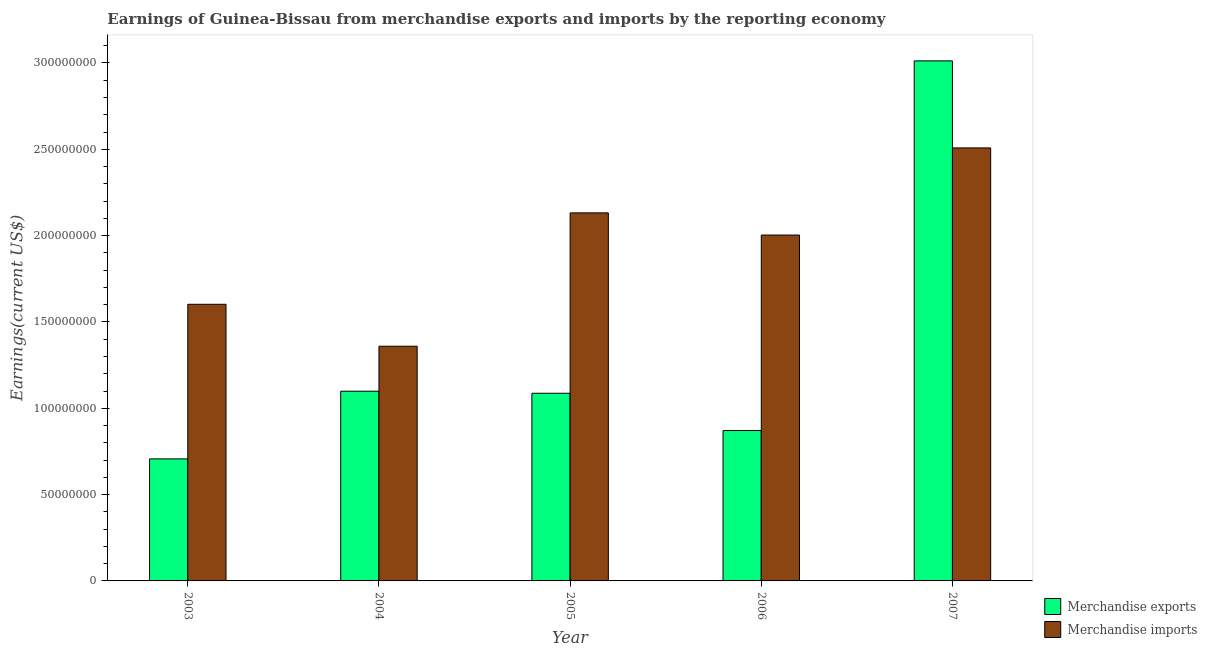Are the number of bars on each tick of the X-axis equal?
Make the answer very short. Yes. How many bars are there on the 1st tick from the right?
Ensure brevity in your answer.  2. What is the label of the 3rd group of bars from the left?
Keep it short and to the point. 2005. What is the earnings from merchandise exports in 2003?
Provide a short and direct response. 7.07e+07. Across all years, what is the maximum earnings from merchandise imports?
Offer a very short reply. 2.51e+08. Across all years, what is the minimum earnings from merchandise exports?
Offer a terse response. 7.07e+07. In which year was the earnings from merchandise exports maximum?
Give a very brief answer. 2007. What is the total earnings from merchandise imports in the graph?
Offer a terse response. 9.61e+08. What is the difference between the earnings from merchandise imports in 2003 and that in 2005?
Offer a terse response. -5.30e+07. What is the difference between the earnings from merchandise imports in 2003 and the earnings from merchandise exports in 2006?
Give a very brief answer. -4.01e+07. What is the average earnings from merchandise imports per year?
Provide a short and direct response. 1.92e+08. In the year 2007, what is the difference between the earnings from merchandise imports and earnings from merchandise exports?
Your response must be concise. 0. In how many years, is the earnings from merchandise imports greater than 40000000 US$?
Give a very brief answer. 5. What is the ratio of the earnings from merchandise imports in 2003 to that in 2007?
Your response must be concise. 0.64. Is the earnings from merchandise imports in 2003 less than that in 2005?
Provide a short and direct response. Yes. Is the difference between the earnings from merchandise exports in 2004 and 2006 greater than the difference between the earnings from merchandise imports in 2004 and 2006?
Your response must be concise. No. What is the difference between the highest and the second highest earnings from merchandise imports?
Provide a succinct answer. 3.76e+07. What is the difference between the highest and the lowest earnings from merchandise imports?
Ensure brevity in your answer.  1.15e+08. How many bars are there?
Give a very brief answer. 10. Are all the bars in the graph horizontal?
Keep it short and to the point. No. How many years are there in the graph?
Give a very brief answer. 5. How are the legend labels stacked?
Ensure brevity in your answer.  Vertical. What is the title of the graph?
Make the answer very short. Earnings of Guinea-Bissau from merchandise exports and imports by the reporting economy. Does "Number of departures" appear as one of the legend labels in the graph?
Provide a short and direct response. No. What is the label or title of the Y-axis?
Provide a short and direct response. Earnings(current US$). What is the Earnings(current US$) in Merchandise exports in 2003?
Give a very brief answer. 7.07e+07. What is the Earnings(current US$) of Merchandise imports in 2003?
Your answer should be compact. 1.60e+08. What is the Earnings(current US$) in Merchandise exports in 2004?
Ensure brevity in your answer.  1.10e+08. What is the Earnings(current US$) of Merchandise imports in 2004?
Keep it short and to the point. 1.36e+08. What is the Earnings(current US$) of Merchandise exports in 2005?
Your response must be concise. 1.09e+08. What is the Earnings(current US$) in Merchandise imports in 2005?
Keep it short and to the point. 2.13e+08. What is the Earnings(current US$) of Merchandise exports in 2006?
Your answer should be compact. 8.71e+07. What is the Earnings(current US$) in Merchandise imports in 2006?
Make the answer very short. 2.00e+08. What is the Earnings(current US$) of Merchandise exports in 2007?
Ensure brevity in your answer.  3.01e+08. What is the Earnings(current US$) of Merchandise imports in 2007?
Make the answer very short. 2.51e+08. Across all years, what is the maximum Earnings(current US$) of Merchandise exports?
Your answer should be very brief. 3.01e+08. Across all years, what is the maximum Earnings(current US$) in Merchandise imports?
Your response must be concise. 2.51e+08. Across all years, what is the minimum Earnings(current US$) of Merchandise exports?
Offer a terse response. 7.07e+07. Across all years, what is the minimum Earnings(current US$) of Merchandise imports?
Your answer should be compact. 1.36e+08. What is the total Earnings(current US$) in Merchandise exports in the graph?
Ensure brevity in your answer.  6.78e+08. What is the total Earnings(current US$) of Merchandise imports in the graph?
Your answer should be very brief. 9.61e+08. What is the difference between the Earnings(current US$) of Merchandise exports in 2003 and that in 2004?
Offer a very short reply. -3.92e+07. What is the difference between the Earnings(current US$) in Merchandise imports in 2003 and that in 2004?
Ensure brevity in your answer.  2.43e+07. What is the difference between the Earnings(current US$) in Merchandise exports in 2003 and that in 2005?
Make the answer very short. -3.80e+07. What is the difference between the Earnings(current US$) of Merchandise imports in 2003 and that in 2005?
Your answer should be very brief. -5.30e+07. What is the difference between the Earnings(current US$) of Merchandise exports in 2003 and that in 2006?
Ensure brevity in your answer.  -1.64e+07. What is the difference between the Earnings(current US$) in Merchandise imports in 2003 and that in 2006?
Give a very brief answer. -4.01e+07. What is the difference between the Earnings(current US$) of Merchandise exports in 2003 and that in 2007?
Make the answer very short. -2.31e+08. What is the difference between the Earnings(current US$) in Merchandise imports in 2003 and that in 2007?
Make the answer very short. -9.06e+07. What is the difference between the Earnings(current US$) in Merchandise exports in 2004 and that in 2005?
Offer a very short reply. 1.20e+06. What is the difference between the Earnings(current US$) in Merchandise imports in 2004 and that in 2005?
Keep it short and to the point. -7.72e+07. What is the difference between the Earnings(current US$) in Merchandise exports in 2004 and that in 2006?
Give a very brief answer. 2.28e+07. What is the difference between the Earnings(current US$) of Merchandise imports in 2004 and that in 2006?
Provide a succinct answer. -6.44e+07. What is the difference between the Earnings(current US$) of Merchandise exports in 2004 and that in 2007?
Your answer should be very brief. -1.91e+08. What is the difference between the Earnings(current US$) in Merchandise imports in 2004 and that in 2007?
Offer a very short reply. -1.15e+08. What is the difference between the Earnings(current US$) of Merchandise exports in 2005 and that in 2006?
Offer a terse response. 2.16e+07. What is the difference between the Earnings(current US$) of Merchandise imports in 2005 and that in 2006?
Make the answer very short. 1.28e+07. What is the difference between the Earnings(current US$) in Merchandise exports in 2005 and that in 2007?
Provide a short and direct response. -1.93e+08. What is the difference between the Earnings(current US$) of Merchandise imports in 2005 and that in 2007?
Provide a succinct answer. -3.76e+07. What is the difference between the Earnings(current US$) in Merchandise exports in 2006 and that in 2007?
Provide a succinct answer. -2.14e+08. What is the difference between the Earnings(current US$) of Merchandise imports in 2006 and that in 2007?
Provide a succinct answer. -5.05e+07. What is the difference between the Earnings(current US$) in Merchandise exports in 2003 and the Earnings(current US$) in Merchandise imports in 2004?
Make the answer very short. -6.53e+07. What is the difference between the Earnings(current US$) in Merchandise exports in 2003 and the Earnings(current US$) in Merchandise imports in 2005?
Your response must be concise. -1.43e+08. What is the difference between the Earnings(current US$) in Merchandise exports in 2003 and the Earnings(current US$) in Merchandise imports in 2006?
Make the answer very short. -1.30e+08. What is the difference between the Earnings(current US$) in Merchandise exports in 2003 and the Earnings(current US$) in Merchandise imports in 2007?
Make the answer very short. -1.80e+08. What is the difference between the Earnings(current US$) of Merchandise exports in 2004 and the Earnings(current US$) of Merchandise imports in 2005?
Keep it short and to the point. -1.03e+08. What is the difference between the Earnings(current US$) of Merchandise exports in 2004 and the Earnings(current US$) of Merchandise imports in 2006?
Make the answer very short. -9.04e+07. What is the difference between the Earnings(current US$) in Merchandise exports in 2004 and the Earnings(current US$) in Merchandise imports in 2007?
Your answer should be very brief. -1.41e+08. What is the difference between the Earnings(current US$) of Merchandise exports in 2005 and the Earnings(current US$) of Merchandise imports in 2006?
Your answer should be very brief. -9.16e+07. What is the difference between the Earnings(current US$) of Merchandise exports in 2005 and the Earnings(current US$) of Merchandise imports in 2007?
Ensure brevity in your answer.  -1.42e+08. What is the difference between the Earnings(current US$) in Merchandise exports in 2006 and the Earnings(current US$) in Merchandise imports in 2007?
Offer a very short reply. -1.64e+08. What is the average Earnings(current US$) of Merchandise exports per year?
Make the answer very short. 1.36e+08. What is the average Earnings(current US$) in Merchandise imports per year?
Make the answer very short. 1.92e+08. In the year 2003, what is the difference between the Earnings(current US$) in Merchandise exports and Earnings(current US$) in Merchandise imports?
Give a very brief answer. -8.95e+07. In the year 2004, what is the difference between the Earnings(current US$) in Merchandise exports and Earnings(current US$) in Merchandise imports?
Give a very brief answer. -2.60e+07. In the year 2005, what is the difference between the Earnings(current US$) in Merchandise exports and Earnings(current US$) in Merchandise imports?
Make the answer very short. -1.04e+08. In the year 2006, what is the difference between the Earnings(current US$) of Merchandise exports and Earnings(current US$) of Merchandise imports?
Your answer should be compact. -1.13e+08. In the year 2007, what is the difference between the Earnings(current US$) of Merchandise exports and Earnings(current US$) of Merchandise imports?
Provide a short and direct response. 5.04e+07. What is the ratio of the Earnings(current US$) in Merchandise exports in 2003 to that in 2004?
Provide a succinct answer. 0.64. What is the ratio of the Earnings(current US$) in Merchandise imports in 2003 to that in 2004?
Provide a short and direct response. 1.18. What is the ratio of the Earnings(current US$) in Merchandise exports in 2003 to that in 2005?
Your answer should be compact. 0.65. What is the ratio of the Earnings(current US$) in Merchandise imports in 2003 to that in 2005?
Your answer should be compact. 0.75. What is the ratio of the Earnings(current US$) of Merchandise exports in 2003 to that in 2006?
Ensure brevity in your answer.  0.81. What is the ratio of the Earnings(current US$) of Merchandise imports in 2003 to that in 2006?
Your answer should be very brief. 0.8. What is the ratio of the Earnings(current US$) of Merchandise exports in 2003 to that in 2007?
Provide a succinct answer. 0.23. What is the ratio of the Earnings(current US$) in Merchandise imports in 2003 to that in 2007?
Your answer should be very brief. 0.64. What is the ratio of the Earnings(current US$) in Merchandise exports in 2004 to that in 2005?
Keep it short and to the point. 1.01. What is the ratio of the Earnings(current US$) of Merchandise imports in 2004 to that in 2005?
Ensure brevity in your answer.  0.64. What is the ratio of the Earnings(current US$) in Merchandise exports in 2004 to that in 2006?
Ensure brevity in your answer.  1.26. What is the ratio of the Earnings(current US$) in Merchandise imports in 2004 to that in 2006?
Ensure brevity in your answer.  0.68. What is the ratio of the Earnings(current US$) in Merchandise exports in 2004 to that in 2007?
Make the answer very short. 0.36. What is the ratio of the Earnings(current US$) of Merchandise imports in 2004 to that in 2007?
Provide a succinct answer. 0.54. What is the ratio of the Earnings(current US$) of Merchandise exports in 2005 to that in 2006?
Provide a short and direct response. 1.25. What is the ratio of the Earnings(current US$) in Merchandise imports in 2005 to that in 2006?
Ensure brevity in your answer.  1.06. What is the ratio of the Earnings(current US$) in Merchandise exports in 2005 to that in 2007?
Keep it short and to the point. 0.36. What is the ratio of the Earnings(current US$) of Merchandise imports in 2005 to that in 2007?
Keep it short and to the point. 0.85. What is the ratio of the Earnings(current US$) of Merchandise exports in 2006 to that in 2007?
Keep it short and to the point. 0.29. What is the ratio of the Earnings(current US$) of Merchandise imports in 2006 to that in 2007?
Your response must be concise. 0.8. What is the difference between the highest and the second highest Earnings(current US$) in Merchandise exports?
Offer a terse response. 1.91e+08. What is the difference between the highest and the second highest Earnings(current US$) of Merchandise imports?
Ensure brevity in your answer.  3.76e+07. What is the difference between the highest and the lowest Earnings(current US$) of Merchandise exports?
Provide a succinct answer. 2.31e+08. What is the difference between the highest and the lowest Earnings(current US$) in Merchandise imports?
Your answer should be very brief. 1.15e+08. 